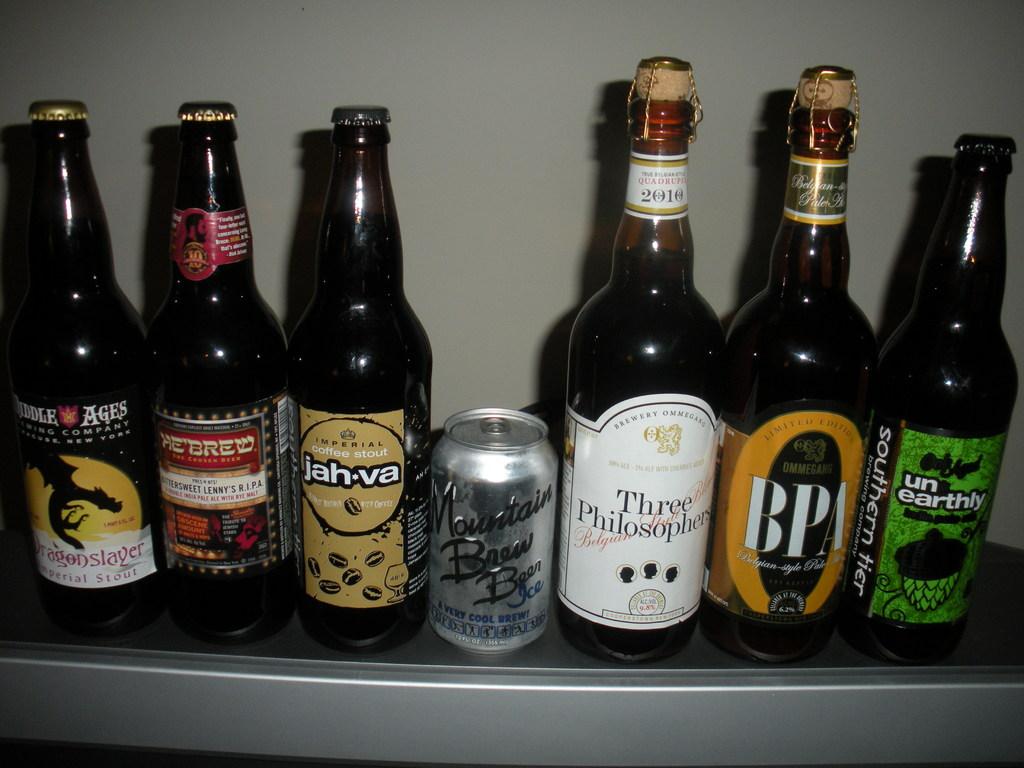What is the third beer on the left called?
Your answer should be compact. Jah-va. 